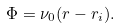<formula> <loc_0><loc_0><loc_500><loc_500>\Phi = \nu _ { 0 } ( r - r _ { i } ) .</formula> 